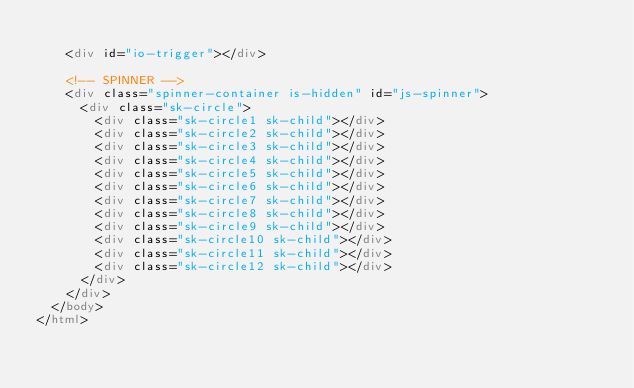Convert code to text. <code><loc_0><loc_0><loc_500><loc_500><_HTML_>
    <div id="io-trigger"></div>

    <!-- SPINNER -->
    <div class="spinner-container is-hidden" id="js-spinner">
      <div class="sk-circle">
        <div class="sk-circle1 sk-child"></div>
        <div class="sk-circle2 sk-child"></div>
        <div class="sk-circle3 sk-child"></div>
        <div class="sk-circle4 sk-child"></div>
        <div class="sk-circle5 sk-child"></div>
        <div class="sk-circle6 sk-child"></div>
        <div class="sk-circle7 sk-child"></div>
        <div class="sk-circle8 sk-child"></div>
        <div class="sk-circle9 sk-child"></div>
        <div class="sk-circle10 sk-child"></div>
        <div class="sk-circle11 sk-child"></div>
        <div class="sk-circle12 sk-child"></div>
      </div>
    </div>
  </body>
</html>
</code> 